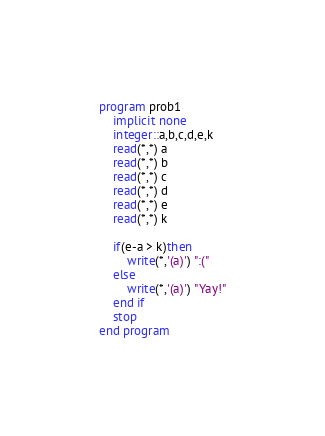Convert code to text. <code><loc_0><loc_0><loc_500><loc_500><_FORTRAN_>program prob1
    implicit none
    integer::a,b,c,d,e,k
    read(*,*) a
    read(*,*) b
    read(*,*) c
    read(*,*) d
    read(*,*) e
    read(*,*) k

    if(e-a > k)then
        write(*,'(a)') ":("
    else
        write(*,'(a)') "Yay!"
    end if
    stop
end program</code> 